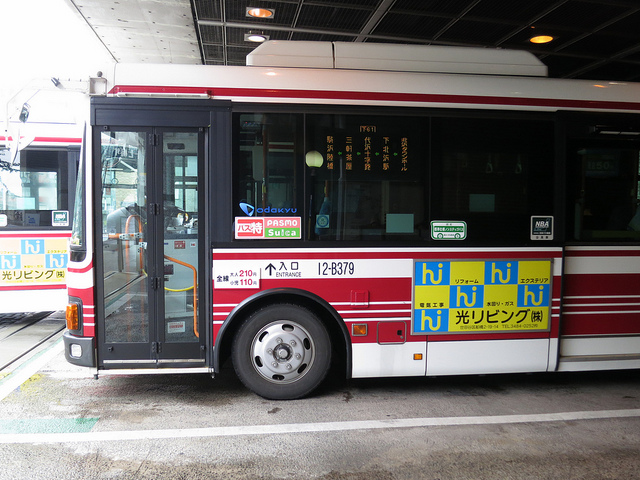Read all the text in this image. 210 12 hj nsA hj hj hi ENTRANCE -B379 